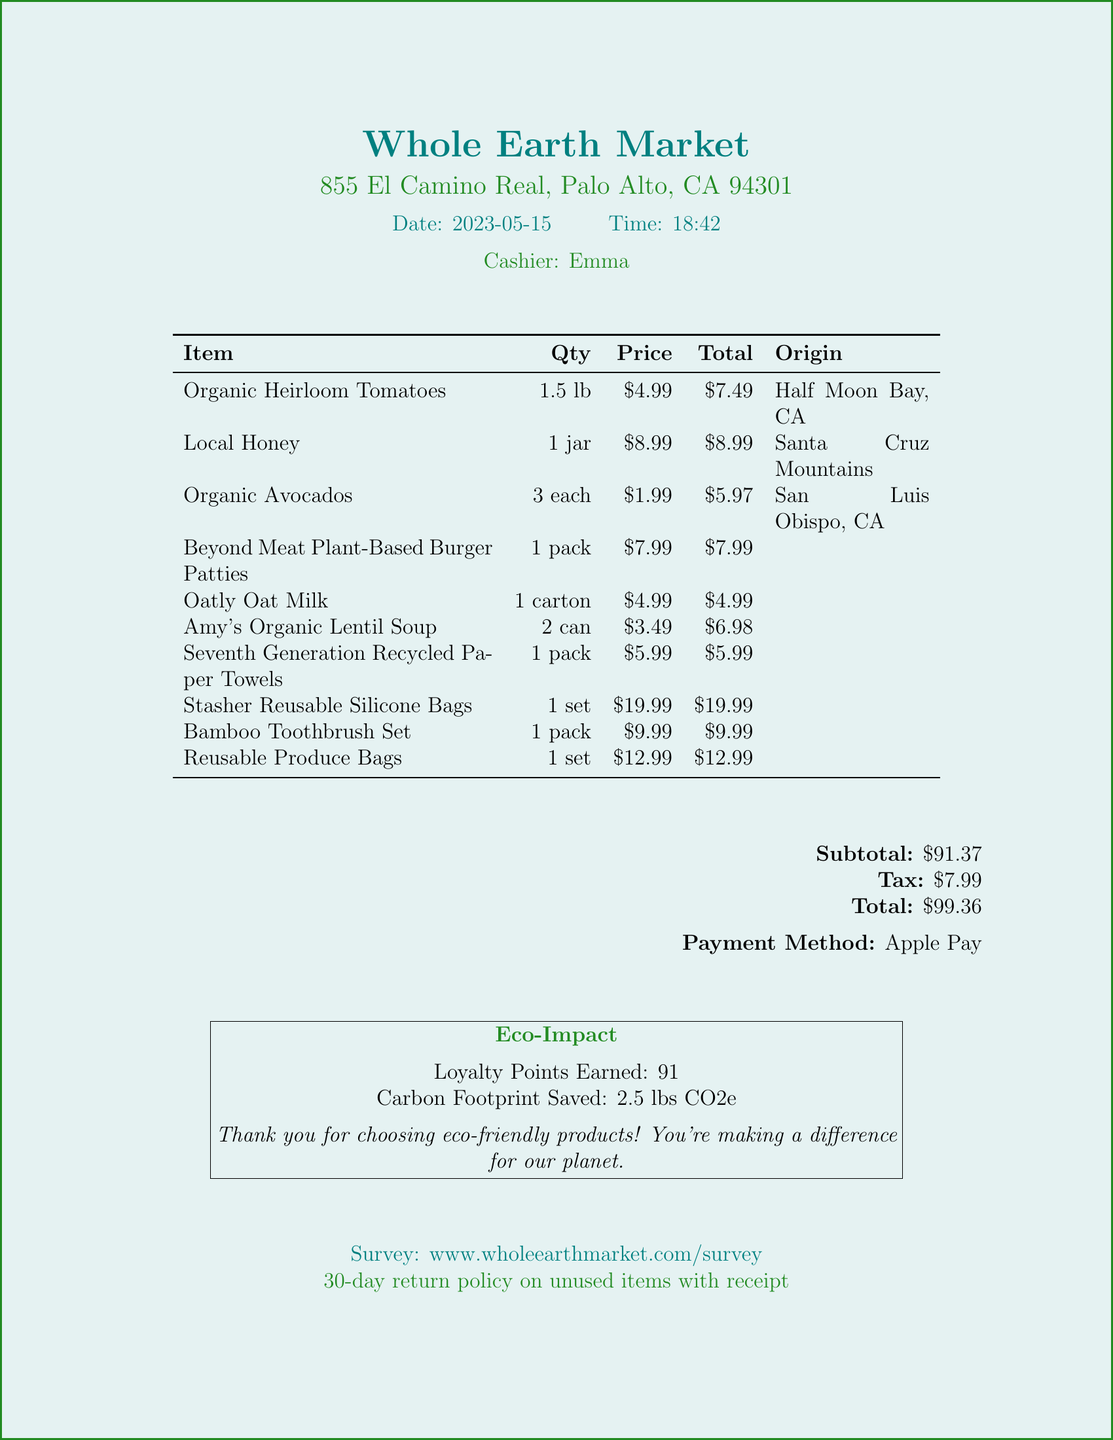What is the name of the store? The store's name is specifically mentioned at the top of the document.
Answer: Whole Earth Market What date was the purchase made? The date is presented clearly in the document under the date section.
Answer: 2023-05-15 What is the total amount of the receipt? The total amount is listed towards the end of the document after the calculations.
Answer: $99.36 How many loyalty points were earned? The loyalty points earned are noted in the eco-impact section of the document.
Answer: 91 What are the origins of the Organic Heirloom Tomatoes? The origin of the tomatoes is specified in the item list.
Answer: Half Moon Bay, CA What is the price of the Stasher Reusable Silicone Bags? The price is clearly shown in the itemized list of the receipt.
Answer: $19.99 What payment method was used for the purchase? The payment method is stated towards the end of the receipt.
Answer: Apple Pay What is the store's return policy duration? The return policy is outlined at the bottom of the document.
Answer: 30-day return policy What product has a carbon footprint saved of 2.5 lbs CO2e? The document mentions the total carbon footprint saved as part of the eco-impact information.
Answer: 2.5 lbs CO2e 